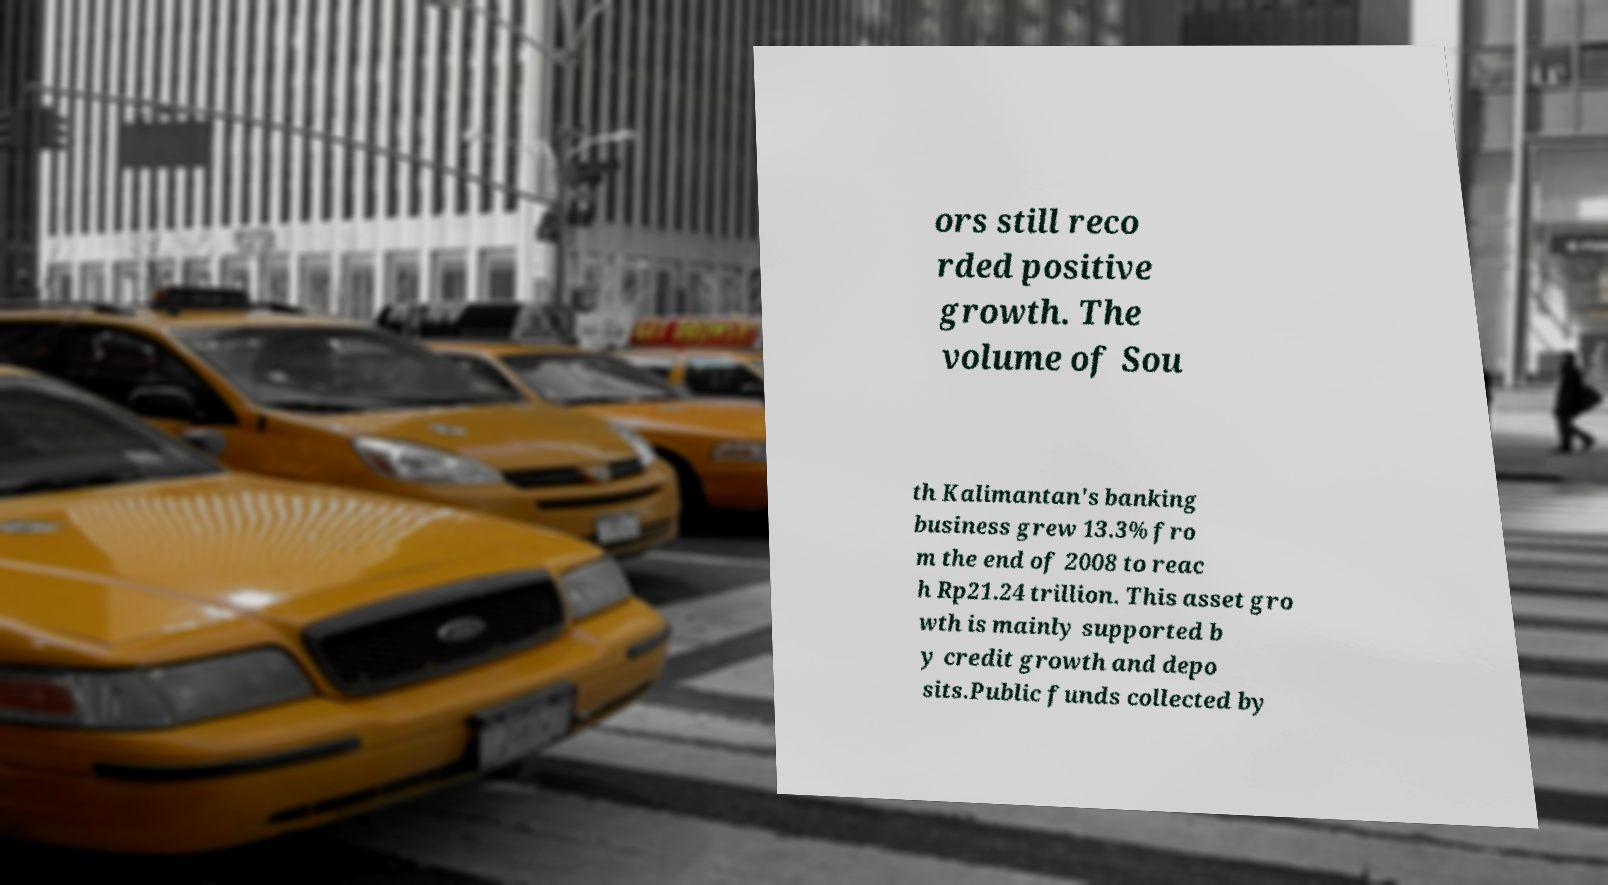Please read and relay the text visible in this image. What does it say? ors still reco rded positive growth. The volume of Sou th Kalimantan's banking business grew 13.3% fro m the end of 2008 to reac h Rp21.24 trillion. This asset gro wth is mainly supported b y credit growth and depo sits.Public funds collected by 